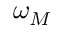Convert formula to latex. <formula><loc_0><loc_0><loc_500><loc_500>\omega _ { M }</formula> 